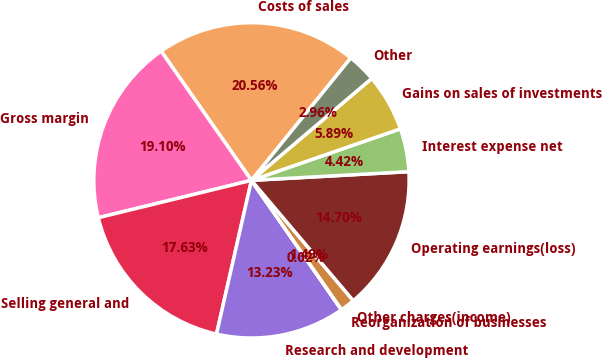Convert chart. <chart><loc_0><loc_0><loc_500><loc_500><pie_chart><fcel>Costs of sales<fcel>Gross margin<fcel>Selling general and<fcel>Research and development<fcel>Reorganization of businesses<fcel>Other charges(income)<fcel>Operating earnings(loss)<fcel>Interest expense net<fcel>Gains on sales of investments<fcel>Other<nl><fcel>20.56%<fcel>19.1%<fcel>17.63%<fcel>13.23%<fcel>0.02%<fcel>1.49%<fcel>14.7%<fcel>4.42%<fcel>5.89%<fcel>2.96%<nl></chart> 